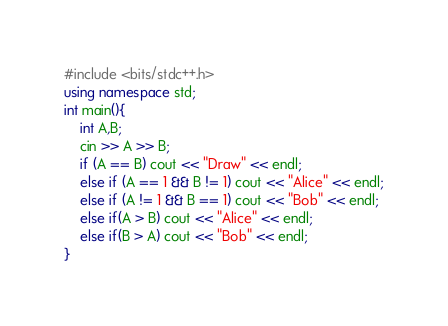Convert code to text. <code><loc_0><loc_0><loc_500><loc_500><_C++_>#include <bits/stdc++.h>
using namespace std;
int main(){
    int A,B;
    cin >> A >> B;
    if (A == B) cout << "Draw" << endl;
    else if (A == 1 && B != 1) cout << "Alice" << endl;
    else if (A != 1 && B == 1) cout << "Bob" << endl;
    else if(A > B) cout << "Alice" << endl;
    else if(B > A) cout << "Bob" << endl; 
}</code> 